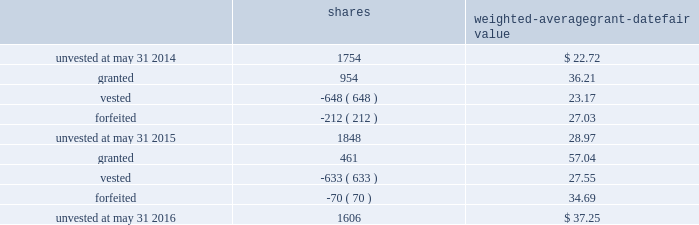Leveraged performance units during fiscal 2015 , certain executives were granted performance units that we refer to as leveraged performance units , or lpus .
Lpus contain a market condition based on our relative stock price growth over a three-year performance period .
The lpus contain a minimum threshold performance which , if not met , would result in no payout .
The lpus also contain a maximum award opportunity set as a fixed dollar and fixed number of shares .
After the three-year performance period , one-third of any earned units converts to unrestricted common stock .
The remaining two-thirds convert to restricted stock that will vest in equal installments on each of the first two anniversaries of the conversion date .
We recognize share-based compensation expense based on the grant date fair value of the lpus , as determined by use of a monte carlo model , on a straight-line basis over the requisite service period for each separately vesting portion of the lpu award .
Total shareholder return units before fiscal 2015 , certain of our executives were granted total shareholder return ( 201ctsr 201d ) units , which are performance-based restricted stock units that are earned based on our total shareholder return over a three-year performance period compared to companies in the s&p 500 .
Once the performance results are certified , tsr units convert into unrestricted common stock .
Depending on our performance , the grantee may earn up to 200% ( 200 % ) of the target number of shares .
The target number of tsr units for each executive is set by the compensation committee .
We recognize share-based compensation expense based on the grant date fair value of the tsr units , as determined by use of a monte carlo model , on a straight-line basis over the vesting period .
The table summarizes the changes in unvested share-based awards for the years ended may 31 , 2016 and 2015 ( shares in thousands ) : shares weighted-average grant-date fair value .
Including the restricted stock , performance units and tsr units described above , the total fair value of share- based awards vested during the years ended may 31 , 2016 , 2015 and 2014 was $ 17.4 million , $ 15.0 million and $ 28.7 million , respectively .
For these share-based awards , we recognized compensation expense of $ 28.8 million , $ 19.8 million and $ 28.2 million in the years ended may 31 , 2016 , 2015 and 2014 , respectively .
As of may 31 , 2016 , there was $ 42.6 million of unrecognized compensation expense related to unvested share-based awards that we expect to recognize over a weighted-average period of 1.9 years .
Our share-based award plans provide for accelerated vesting under certain conditions .
Employee stock purchase plan we have an employee stock purchase plan under which the sale of 4.8 million shares of our common stock has been authorized .
Employees may designate up to the lesser of $ 25000 or 20% ( 20 % ) of their annual compensation for the purchase of our common stock .
The price for shares purchased under the plan is 85% ( 85 % ) of the market value on 84 2013 global payments inc .
| 2016 form 10-k annual report .
What was the change in value of unvested grants from 2014 to 2016? 
Rationale: to find the change in unvested grants one must find the value of each unvested grant by multiplying the price by the amount . the one must subtract the two years from each other to find the change .
Computations: ((1606 * 37.25) - (1754 * 22.72))
Answer: 19972.62. 